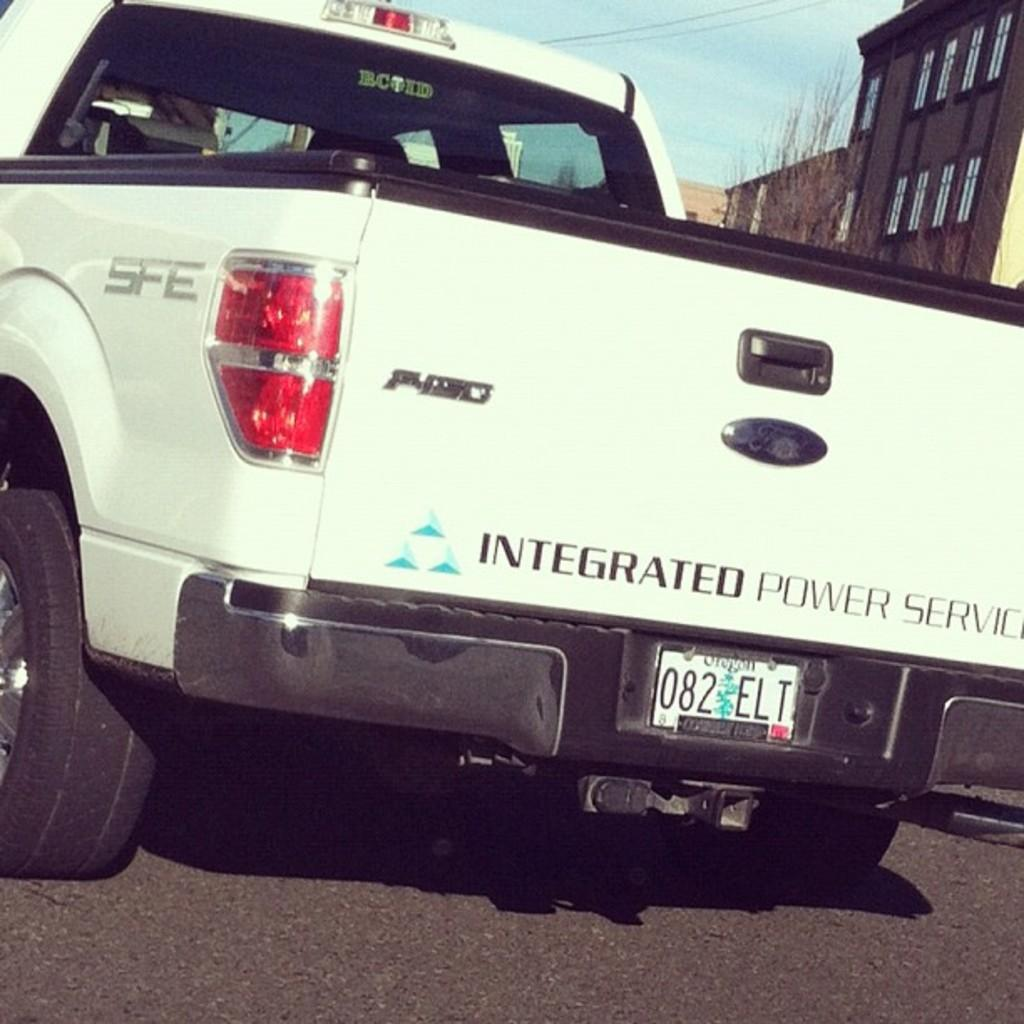What is the main subject of the image? There is a vehicle on the road in the image. What else can be seen in the image besides the vehicle? Buildings and the sky are visible in the top right corner of the image. What type of hobbies does the person in the suit enjoy in the image? There is no person in a suit present in the image, and therefore no information about their hobbies can be determined. 